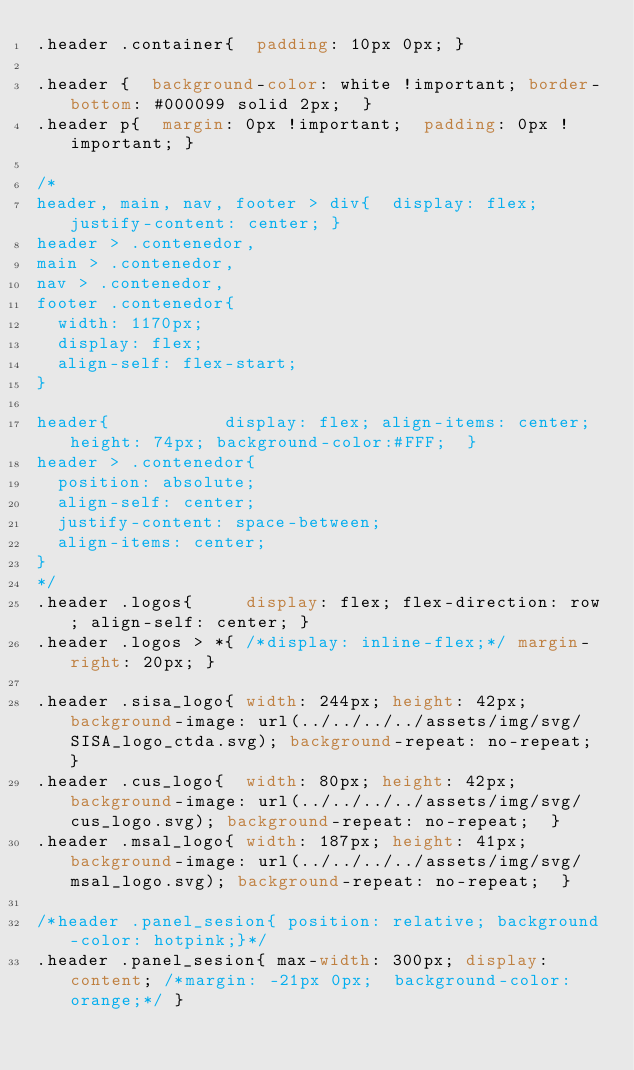<code> <loc_0><loc_0><loc_500><loc_500><_CSS_>.header .container{  padding: 10px 0px; }

.header {  background-color: white !important; border-bottom: #000099 solid 2px;  }
.header p{  margin: 0px !important;  padding: 0px !important; }

/*
header, main, nav, footer > div{	display: flex; justify-content: center;	}
header > .contenedor,
main > .contenedor,
nav > .contenedor,
footer .contenedor{	
	width: 1170px; 
	display: flex;
	align-self: flex-start;
}

header{		    		display: flex; align-items: center; height: 74px; background-color:#FFF;	}
header > .contenedor{	
	position: absolute; 
	align-self: center;
	justify-content: space-between;
	align-items: center;	
}
*/
.header .logos{			display: flex; flex-direction: row; align-self: center; }
.header .logos > *{	/*display: inline-flex;*/ margin-right: 20px;	}

.header .sisa_logo{	width: 244px; height: 42px; background-image: url(../../../../assets/img/svg/SISA_logo_ctda.svg); background-repeat: no-repeat;	}
.header .cus_logo{	width: 80px; height: 42px; background-image: url(../../../../assets/img/svg/cus_logo.svg); background-repeat: no-repeat;	}
.header .msal_logo{	width: 187px; height: 41px; background-image: url(../../../../assets/img/svg/msal_logo.svg); background-repeat: no-repeat;	}

/*header .panel_sesion{ position: relative; background-color: hotpink;}*/
.header .panel_sesion{ max-width: 300px; display: content; /*margin: -21px 0px;  background-color: orange;*/ }</code> 